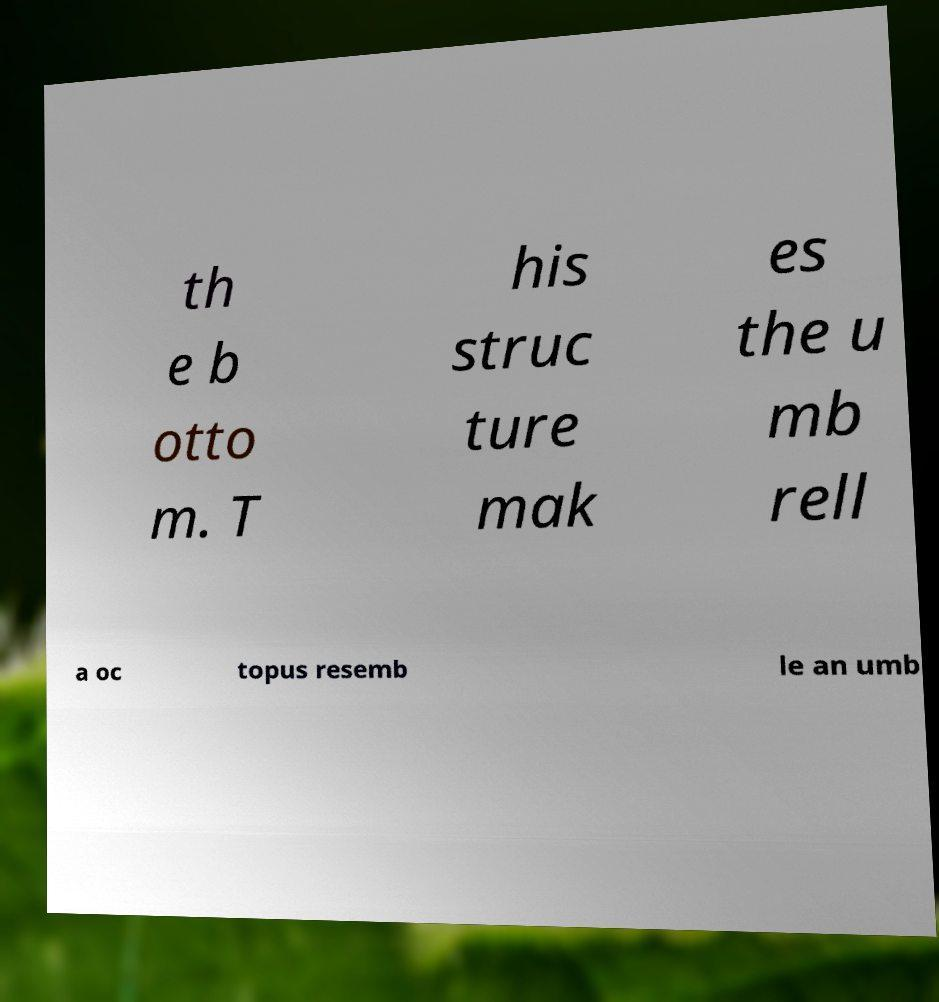Could you assist in decoding the text presented in this image and type it out clearly? th e b otto m. T his struc ture mak es the u mb rell a oc topus resemb le an umb 